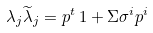Convert formula to latex. <formula><loc_0><loc_0><loc_500><loc_500>\lambda _ { j } \widetilde { \lambda } _ { j } = p ^ { t } \, { 1 } + \Sigma \sigma ^ { i } p ^ { i }</formula> 